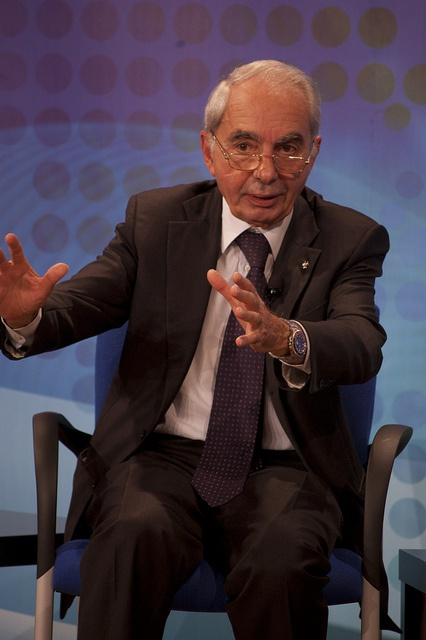Describe the objects in this image and their specific colors. I can see people in purple, black, maroon, and brown tones, chair in purple, black, gray, and maroon tones, and tie in purple, black, and brown tones in this image. 